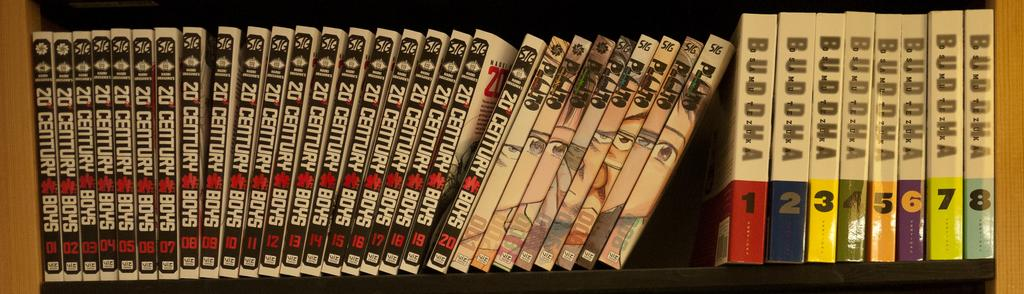<image>
Provide a brief description of the given image. a stack of books on a shelf including 20 Century Boys 